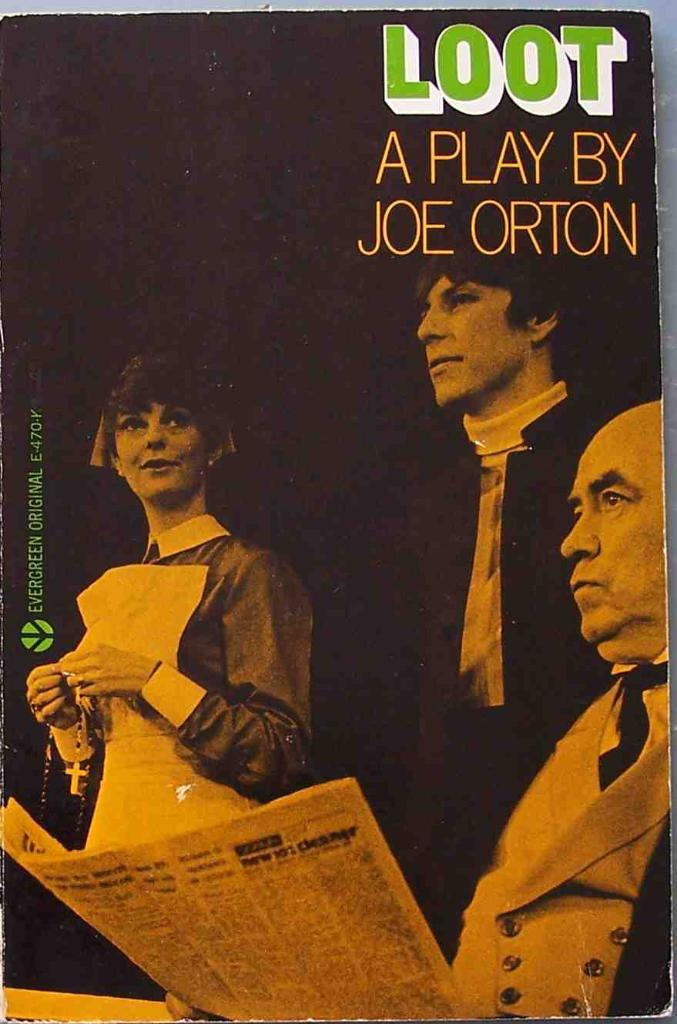<image>
Share a concise interpretation of the image provided. The poster advertises a play that was writte by Joe Orton. 